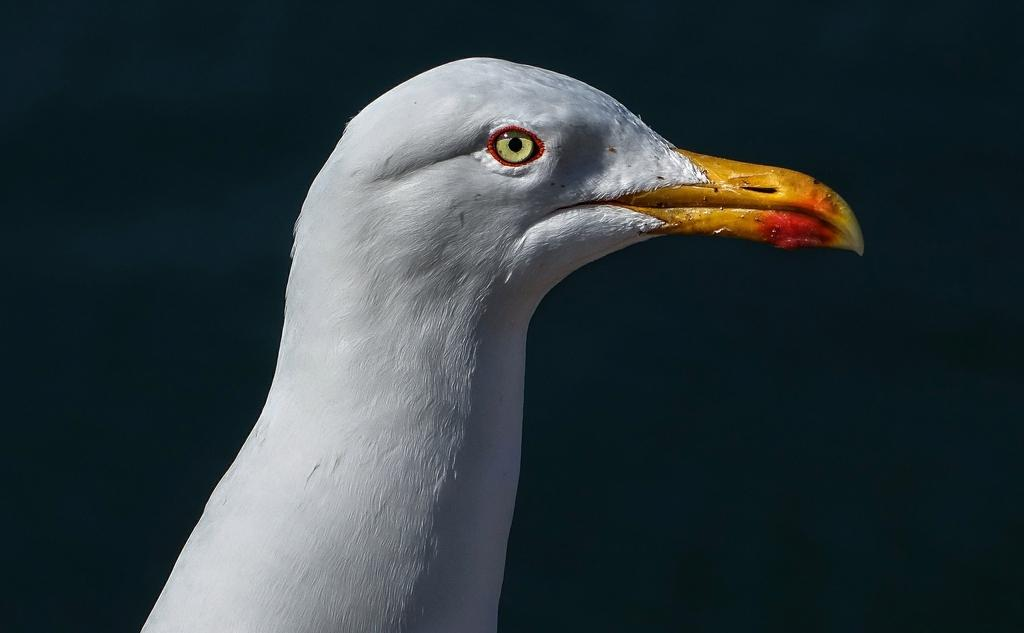What type of animal is present in the image? There is a bird in the image. What color is the bird? The bird is white in color. What can be observed about the background of the image? The background of the image is dark. How many frogs are sitting on the chairs in the image? There are no frogs or chairs present in the image. What type of wall is visible in the image? There is no wall visible in the image; it only features a bird and a dark background. 